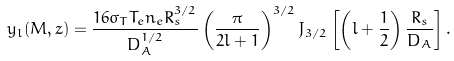Convert formula to latex. <formula><loc_0><loc_0><loc_500><loc_500>y _ { l } ( M , z ) = \frac { 1 6 \sigma _ { T } T _ { e } n _ { e } R _ { s } ^ { 3 / 2 } } { D _ { A } ^ { 1 / 2 } } \left ( \frac { \pi } { 2 l + 1 } \right ) ^ { 3 / 2 } J _ { 3 / 2 } \left [ \left ( l + \frac { 1 } { 2 } \right ) \frac { R _ { s } } { D _ { A } } \right ] .</formula> 